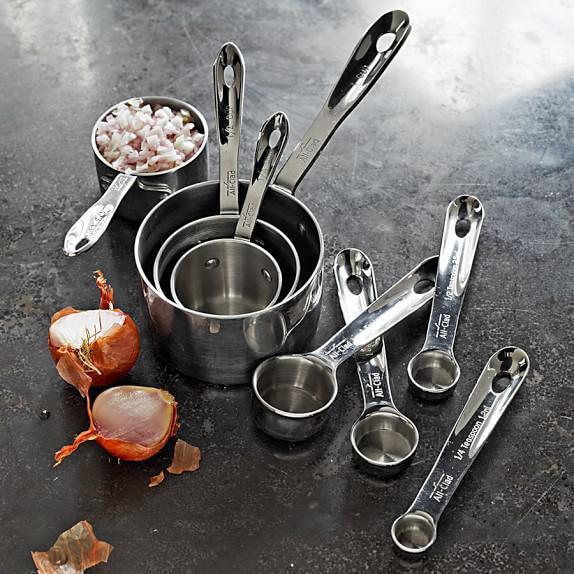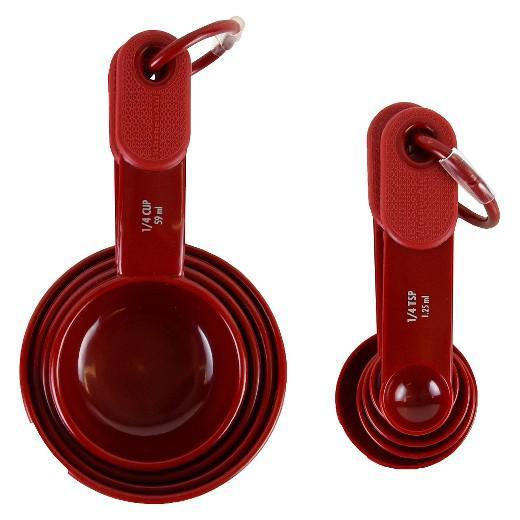The first image is the image on the left, the second image is the image on the right. Considering the images on both sides, is "There is at least clear measuring cup in one of the images." valid? Answer yes or no. No. 